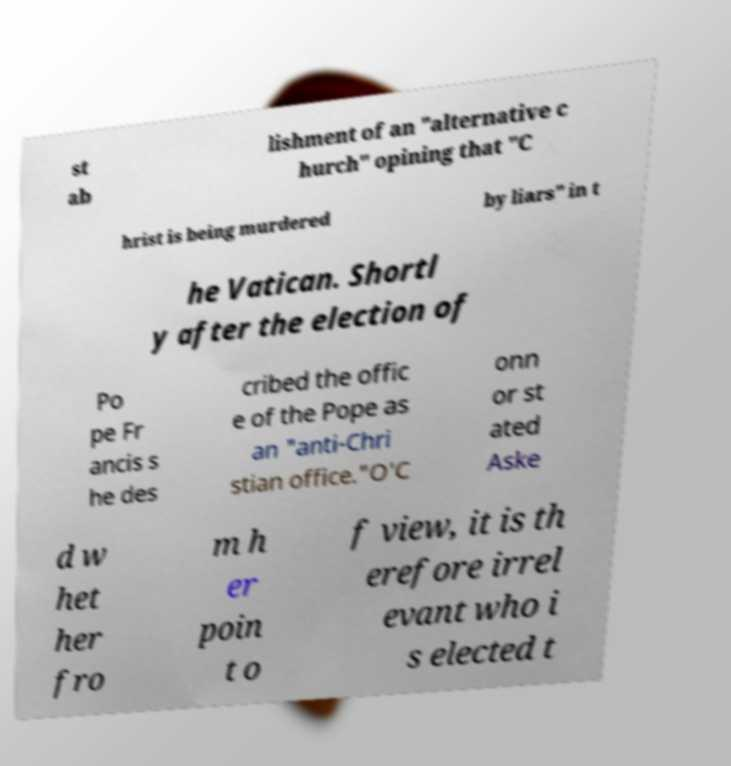Can you read and provide the text displayed in the image?This photo seems to have some interesting text. Can you extract and type it out for me? st ab lishment of an "alternative c hurch" opining that "C hrist is being murdered by liars" in t he Vatican. Shortl y after the election of Po pe Fr ancis s he des cribed the offic e of the Pope as an "anti-Chri stian office."O'C onn or st ated Aske d w het her fro m h er poin t o f view, it is th erefore irrel evant who i s elected t 